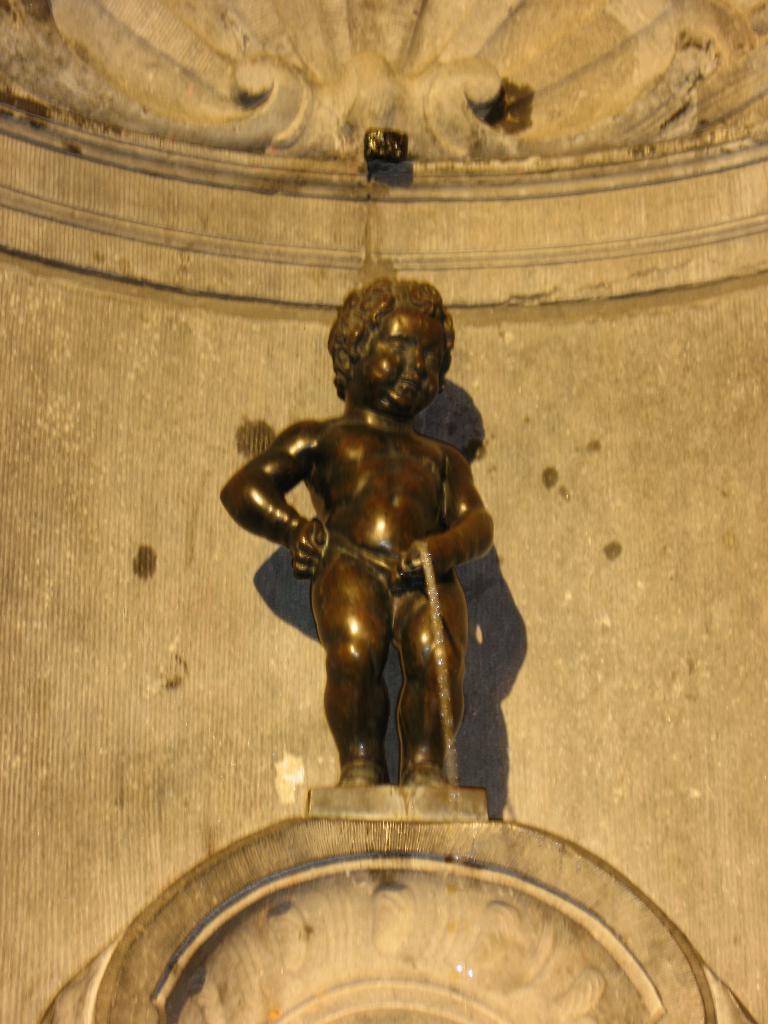Please provide a concise description of this image. In the middle of the image we can see a statue. 